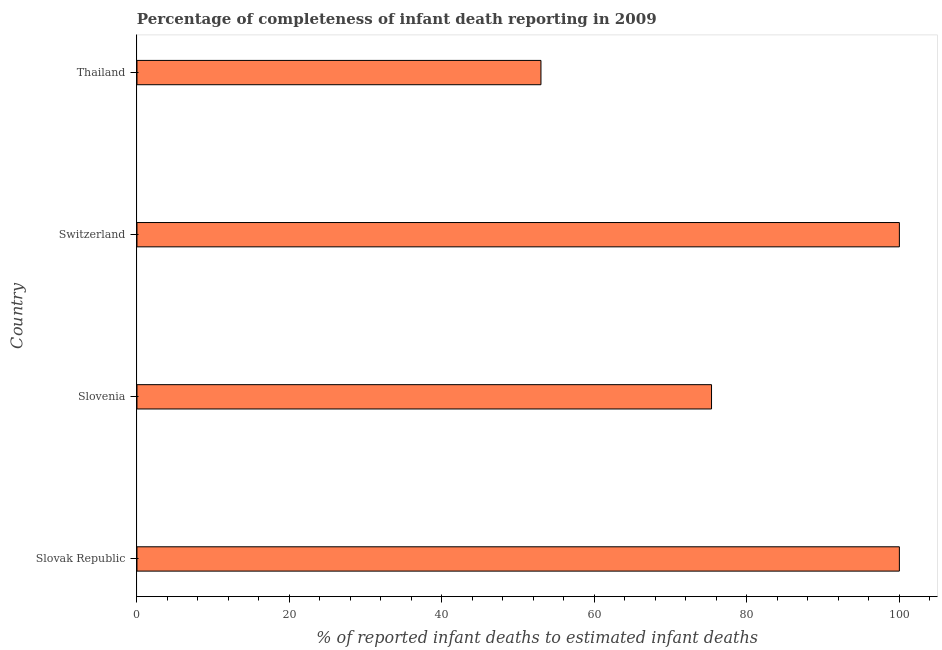Does the graph contain any zero values?
Keep it short and to the point. No. What is the title of the graph?
Provide a short and direct response. Percentage of completeness of infant death reporting in 2009. What is the label or title of the X-axis?
Offer a terse response. % of reported infant deaths to estimated infant deaths. Across all countries, what is the minimum completeness of infant death reporting?
Your answer should be compact. 52.99. In which country was the completeness of infant death reporting maximum?
Offer a terse response. Slovak Republic. In which country was the completeness of infant death reporting minimum?
Your answer should be very brief. Thailand. What is the sum of the completeness of infant death reporting?
Your answer should be compact. 328.35. What is the difference between the completeness of infant death reporting in Switzerland and Thailand?
Ensure brevity in your answer.  47.01. What is the average completeness of infant death reporting per country?
Provide a short and direct response. 82.09. What is the median completeness of infant death reporting?
Your answer should be compact. 87.68. What is the ratio of the completeness of infant death reporting in Slovak Republic to that in Thailand?
Ensure brevity in your answer.  1.89. Is the difference between the completeness of infant death reporting in Slovenia and Switzerland greater than the difference between any two countries?
Your answer should be very brief. No. What is the difference between the highest and the lowest completeness of infant death reporting?
Ensure brevity in your answer.  47.01. How many bars are there?
Keep it short and to the point. 4. What is the % of reported infant deaths to estimated infant deaths in Slovak Republic?
Make the answer very short. 100. What is the % of reported infant deaths to estimated infant deaths in Slovenia?
Your answer should be compact. 75.36. What is the % of reported infant deaths to estimated infant deaths in Thailand?
Make the answer very short. 52.99. What is the difference between the % of reported infant deaths to estimated infant deaths in Slovak Republic and Slovenia?
Your response must be concise. 24.64. What is the difference between the % of reported infant deaths to estimated infant deaths in Slovak Republic and Switzerland?
Give a very brief answer. 0. What is the difference between the % of reported infant deaths to estimated infant deaths in Slovak Republic and Thailand?
Give a very brief answer. 47.01. What is the difference between the % of reported infant deaths to estimated infant deaths in Slovenia and Switzerland?
Give a very brief answer. -24.64. What is the difference between the % of reported infant deaths to estimated infant deaths in Slovenia and Thailand?
Your answer should be very brief. 22.37. What is the difference between the % of reported infant deaths to estimated infant deaths in Switzerland and Thailand?
Your response must be concise. 47.01. What is the ratio of the % of reported infant deaths to estimated infant deaths in Slovak Republic to that in Slovenia?
Your answer should be very brief. 1.33. What is the ratio of the % of reported infant deaths to estimated infant deaths in Slovak Republic to that in Thailand?
Provide a succinct answer. 1.89. What is the ratio of the % of reported infant deaths to estimated infant deaths in Slovenia to that in Switzerland?
Your answer should be very brief. 0.75. What is the ratio of the % of reported infant deaths to estimated infant deaths in Slovenia to that in Thailand?
Offer a terse response. 1.42. What is the ratio of the % of reported infant deaths to estimated infant deaths in Switzerland to that in Thailand?
Offer a very short reply. 1.89. 